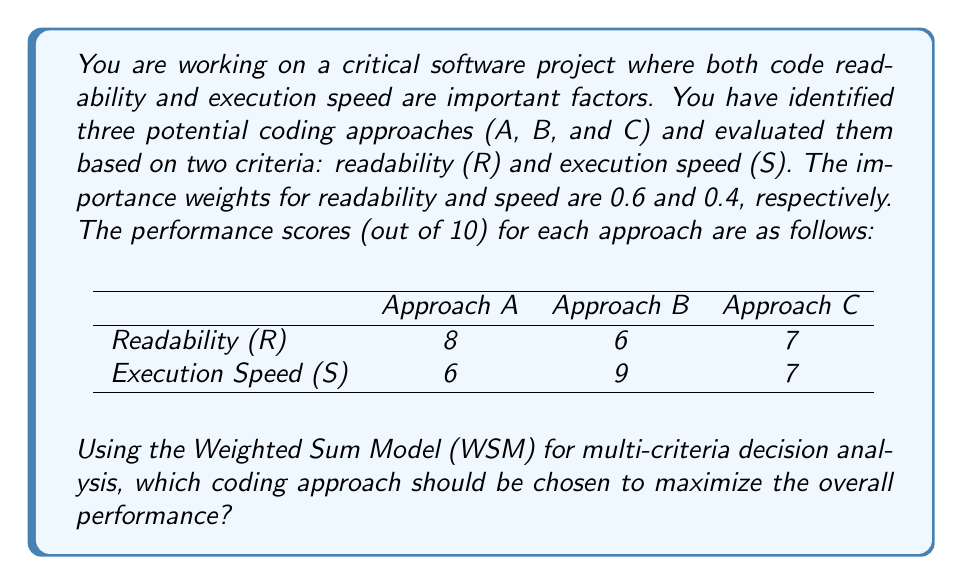Can you answer this question? To solve this problem using the Weighted Sum Model (WSM), we'll follow these steps:

1. Identify the criteria and their weights:
   - Readability (R): weight = 0.6
   - Speed (S): weight = 0.4

2. List the performance scores for each approach:
   - Approach A: R = 8, S = 6
   - Approach B: R = 6, S = 9
   - Approach C: R = 7, S = 7

3. Calculate the weighted score for each approach using the formula:
   $$ \text{Weighted Score} = \sum_{i=1}^n w_i \times x_i $$
   Where $w_i$ is the weight of criterion $i$, and $x_i$ is the performance score for criterion $i$.

   For Approach A:
   $$ \text{Score}_A = (0.6 \times 8) + (0.4 \times 6) = 4.8 + 2.4 = 7.2 $$

   For Approach B:
   $$ \text{Score}_B = (0.6 \times 6) + (0.4 \times 9) = 3.6 + 3.6 = 7.2 $$

   For Approach C:
   $$ \text{Score}_C = (0.6 \times 7) + (0.4 \times 7) = 4.2 + 2.8 = 7.0 $$

4. Compare the weighted scores and choose the approach with the highest score.

   Approach A: 7.2
   Approach B: 7.2
   Approach C: 7.0

We can see that Approaches A and B have the same highest score of 7.2.
Answer: Both Approach A and Approach B are equally optimal, with a weighted score of 7.2. The choice between them would depend on additional factors or preferences not captured in this analysis. 